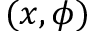<formula> <loc_0><loc_0><loc_500><loc_500>( x , \phi )</formula> 